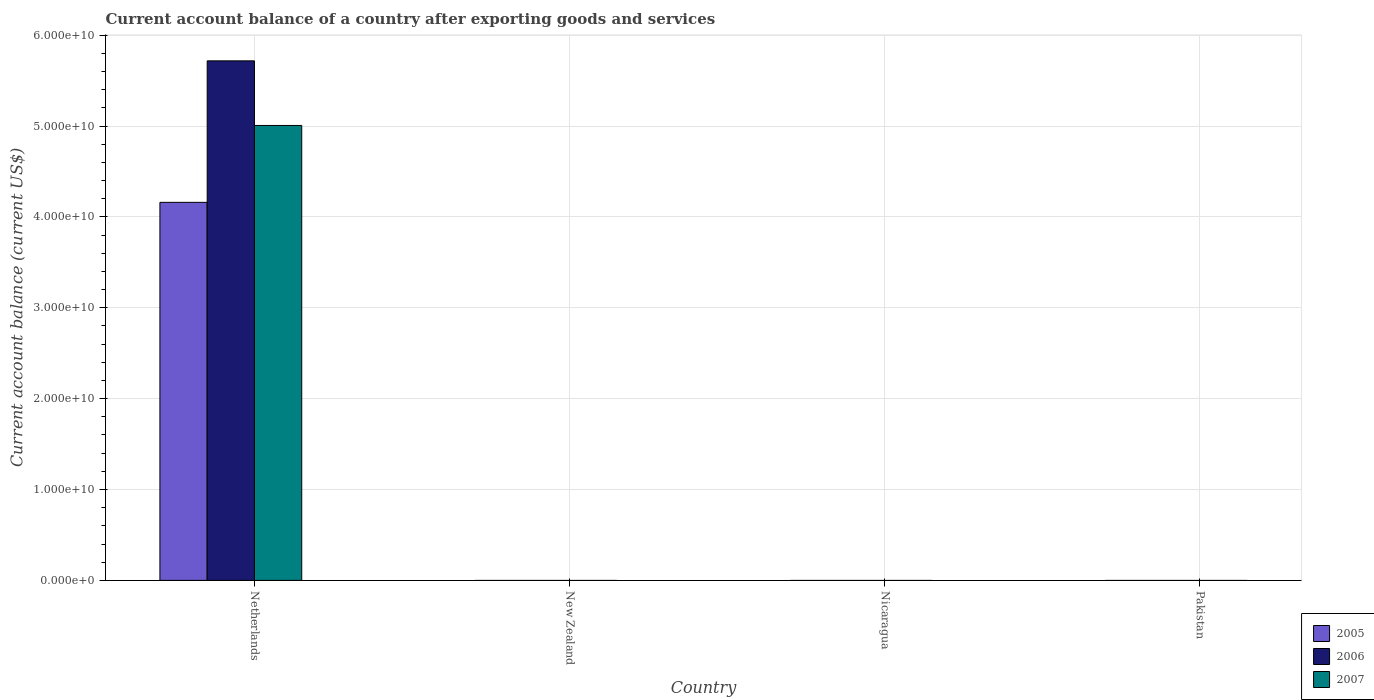How many different coloured bars are there?
Provide a short and direct response. 3. Are the number of bars per tick equal to the number of legend labels?
Ensure brevity in your answer.  No. Are the number of bars on each tick of the X-axis equal?
Make the answer very short. No. What is the label of the 2nd group of bars from the left?
Offer a very short reply. New Zealand. Across all countries, what is the maximum account balance in 2007?
Keep it short and to the point. 5.01e+1. Across all countries, what is the minimum account balance in 2005?
Ensure brevity in your answer.  0. What is the total account balance in 2007 in the graph?
Your answer should be very brief. 5.01e+1. What is the difference between the account balance in 2007 in Nicaragua and the account balance in 2005 in Netherlands?
Ensure brevity in your answer.  -4.16e+1. What is the average account balance in 2006 per country?
Give a very brief answer. 1.43e+1. What is the difference between the account balance of/in 2005 and account balance of/in 2006 in Netherlands?
Provide a succinct answer. -1.56e+1. In how many countries, is the account balance in 2007 greater than 40000000000 US$?
Offer a terse response. 1. What is the difference between the highest and the lowest account balance in 2006?
Keep it short and to the point. 5.72e+1. In how many countries, is the account balance in 2007 greater than the average account balance in 2007 taken over all countries?
Provide a short and direct response. 1. Is it the case that in every country, the sum of the account balance in 2007 and account balance in 2005 is greater than the account balance in 2006?
Provide a short and direct response. No. How many bars are there?
Offer a very short reply. 3. Are all the bars in the graph horizontal?
Offer a terse response. No. How many countries are there in the graph?
Ensure brevity in your answer.  4. What is the difference between two consecutive major ticks on the Y-axis?
Make the answer very short. 1.00e+1. Are the values on the major ticks of Y-axis written in scientific E-notation?
Your response must be concise. Yes. Does the graph contain grids?
Offer a terse response. Yes. How many legend labels are there?
Ensure brevity in your answer.  3. What is the title of the graph?
Offer a terse response. Current account balance of a country after exporting goods and services. Does "1979" appear as one of the legend labels in the graph?
Your answer should be compact. No. What is the label or title of the Y-axis?
Offer a very short reply. Current account balance (current US$). What is the Current account balance (current US$) in 2005 in Netherlands?
Your answer should be compact. 4.16e+1. What is the Current account balance (current US$) of 2006 in Netherlands?
Offer a terse response. 5.72e+1. What is the Current account balance (current US$) of 2007 in Netherlands?
Make the answer very short. 5.01e+1. What is the Current account balance (current US$) of 2005 in New Zealand?
Keep it short and to the point. 0. What is the Current account balance (current US$) in 2005 in Nicaragua?
Give a very brief answer. 0. What is the Current account balance (current US$) of 2006 in Nicaragua?
Give a very brief answer. 0. What is the Current account balance (current US$) of 2006 in Pakistan?
Your answer should be very brief. 0. Across all countries, what is the maximum Current account balance (current US$) in 2005?
Provide a short and direct response. 4.16e+1. Across all countries, what is the maximum Current account balance (current US$) of 2006?
Offer a very short reply. 5.72e+1. Across all countries, what is the maximum Current account balance (current US$) in 2007?
Ensure brevity in your answer.  5.01e+1. Across all countries, what is the minimum Current account balance (current US$) in 2005?
Offer a very short reply. 0. Across all countries, what is the minimum Current account balance (current US$) in 2006?
Provide a short and direct response. 0. What is the total Current account balance (current US$) in 2005 in the graph?
Provide a succinct answer. 4.16e+1. What is the total Current account balance (current US$) of 2006 in the graph?
Offer a terse response. 5.72e+1. What is the total Current account balance (current US$) in 2007 in the graph?
Offer a terse response. 5.01e+1. What is the average Current account balance (current US$) of 2005 per country?
Offer a terse response. 1.04e+1. What is the average Current account balance (current US$) of 2006 per country?
Make the answer very short. 1.43e+1. What is the average Current account balance (current US$) in 2007 per country?
Provide a succinct answer. 1.25e+1. What is the difference between the Current account balance (current US$) of 2005 and Current account balance (current US$) of 2006 in Netherlands?
Ensure brevity in your answer.  -1.56e+1. What is the difference between the Current account balance (current US$) in 2005 and Current account balance (current US$) in 2007 in Netherlands?
Offer a very short reply. -8.46e+09. What is the difference between the Current account balance (current US$) in 2006 and Current account balance (current US$) in 2007 in Netherlands?
Make the answer very short. 7.11e+09. What is the difference between the highest and the lowest Current account balance (current US$) of 2005?
Offer a very short reply. 4.16e+1. What is the difference between the highest and the lowest Current account balance (current US$) of 2006?
Keep it short and to the point. 5.72e+1. What is the difference between the highest and the lowest Current account balance (current US$) of 2007?
Keep it short and to the point. 5.01e+1. 